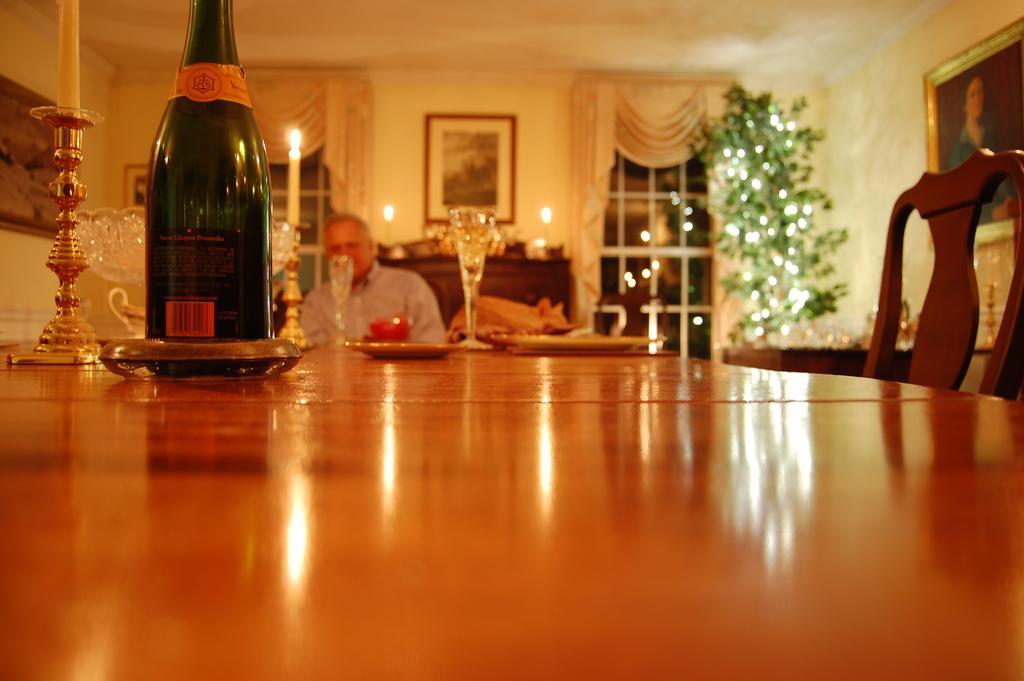Describe this image in one or two sentences. In this image, There is a table which is in yellow color, There is a bottle kept which is in green color, There are some glasses on the table, There are some plates on the table, There is a chair which is in yellow color, In the background there is a person sitting on the chair, There is a white color wall and there is a picture in the middle of the wall. 